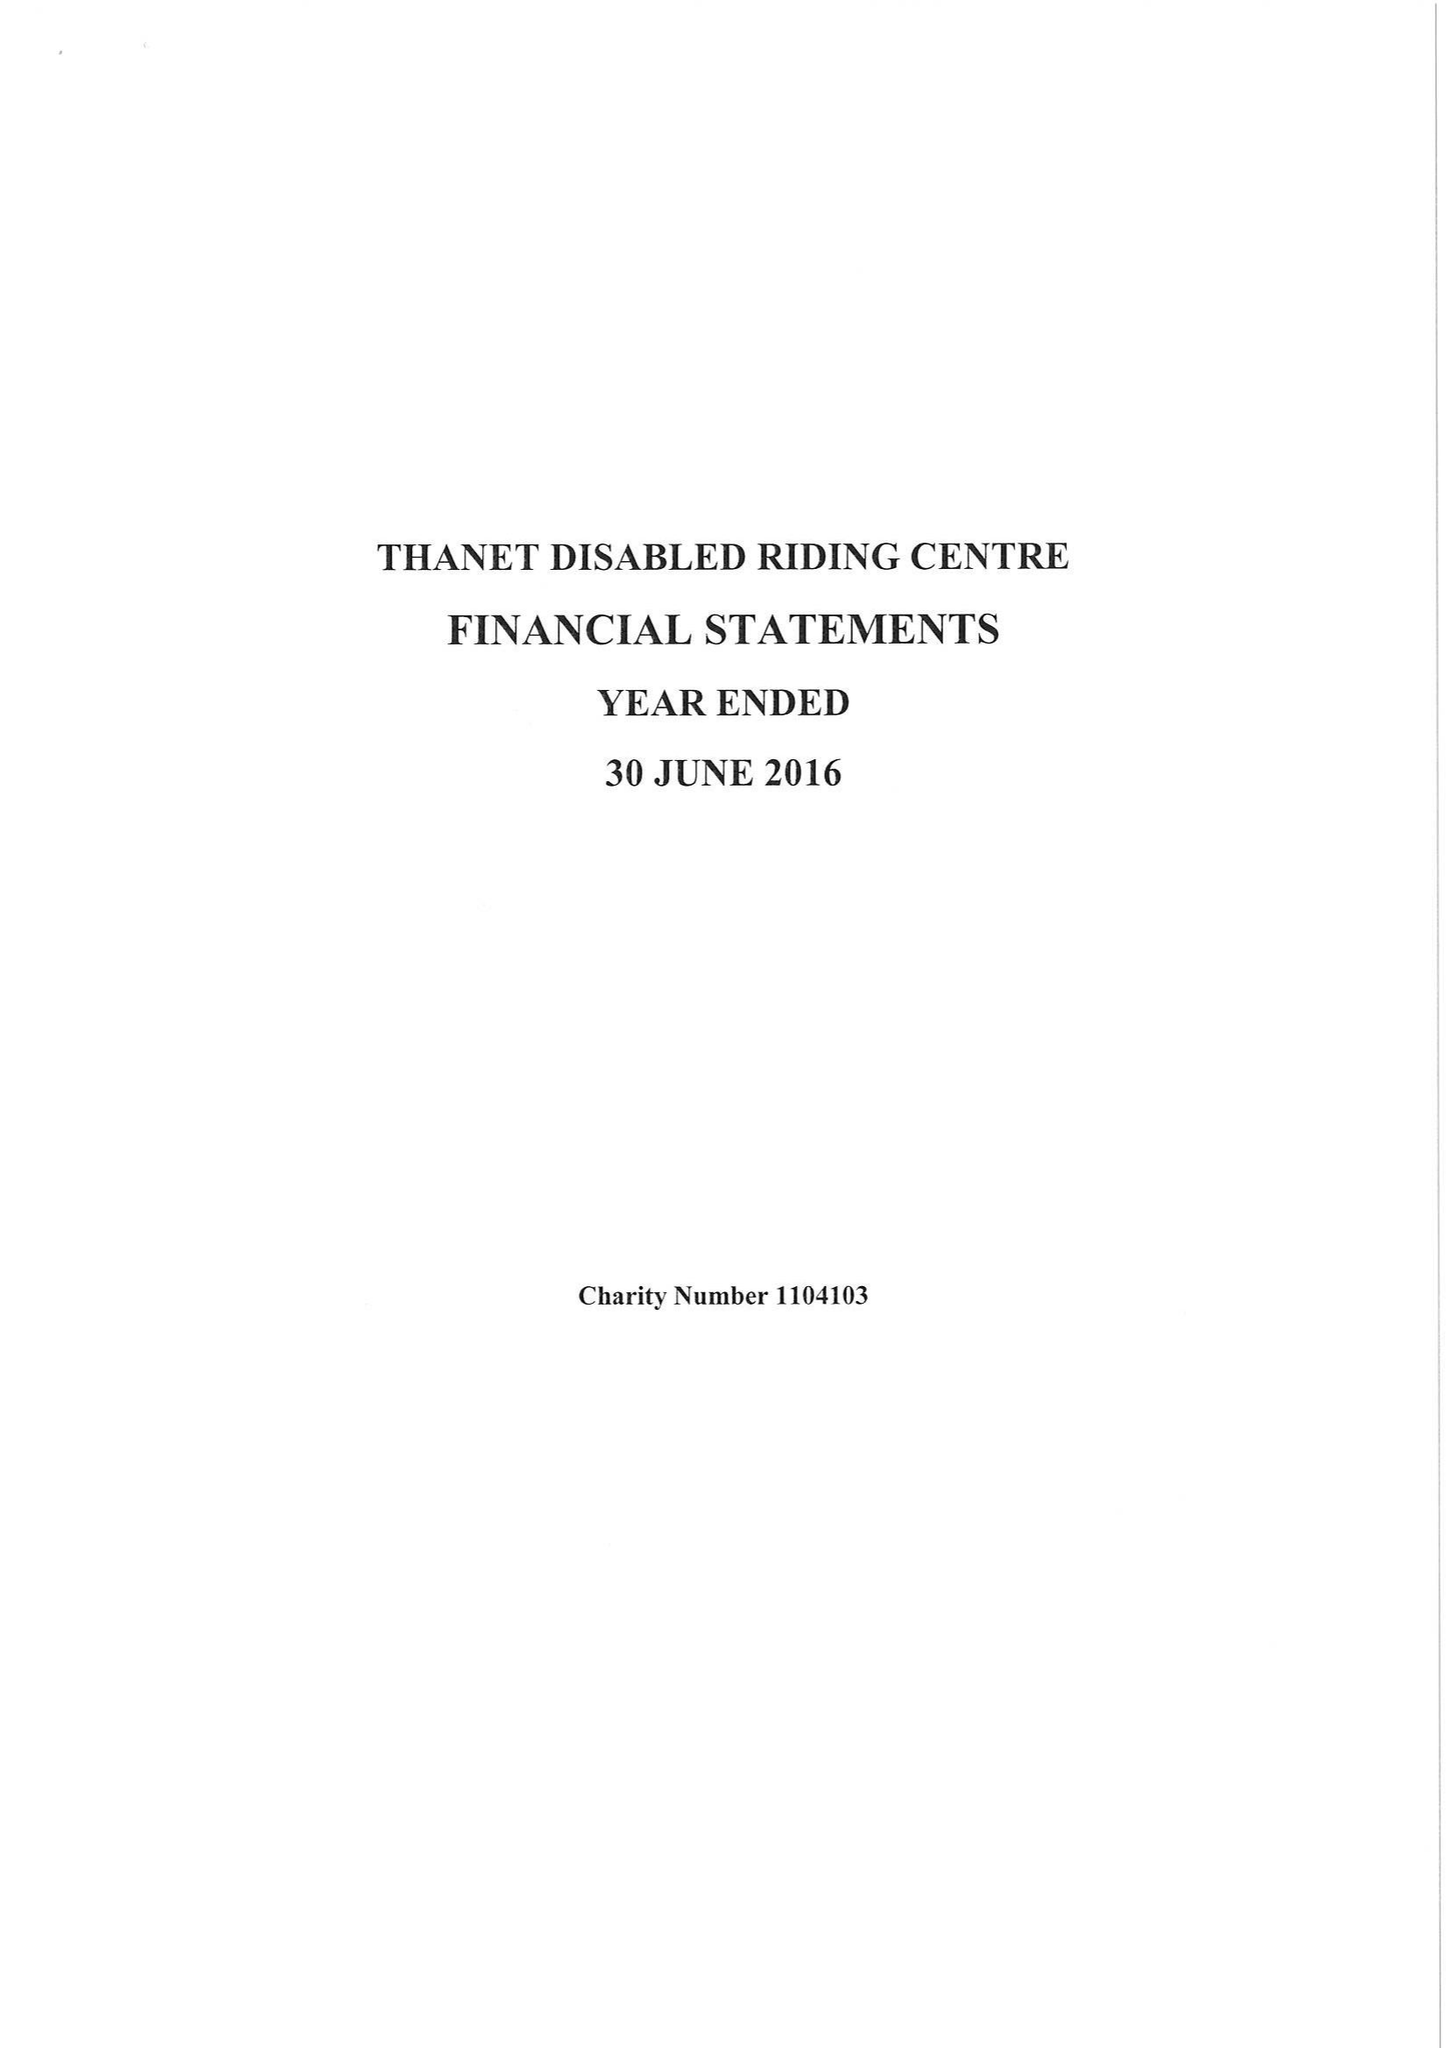What is the value for the address__post_town?
Answer the question using a single word or phrase. BROADSTAIRS 